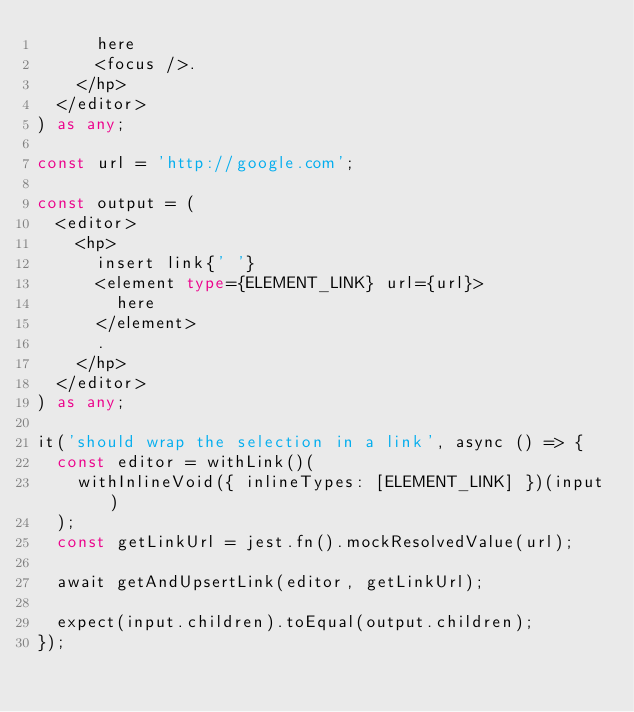<code> <loc_0><loc_0><loc_500><loc_500><_TypeScript_>      here
      <focus />.
    </hp>
  </editor>
) as any;

const url = 'http://google.com';

const output = (
  <editor>
    <hp>
      insert link{' '}
      <element type={ELEMENT_LINK} url={url}>
        here
      </element>
      .
    </hp>
  </editor>
) as any;

it('should wrap the selection in a link', async () => {
  const editor = withLink()(
    withInlineVoid({ inlineTypes: [ELEMENT_LINK] })(input)
  );
  const getLinkUrl = jest.fn().mockResolvedValue(url);

  await getAndUpsertLink(editor, getLinkUrl);

  expect(input.children).toEqual(output.children);
});
</code> 